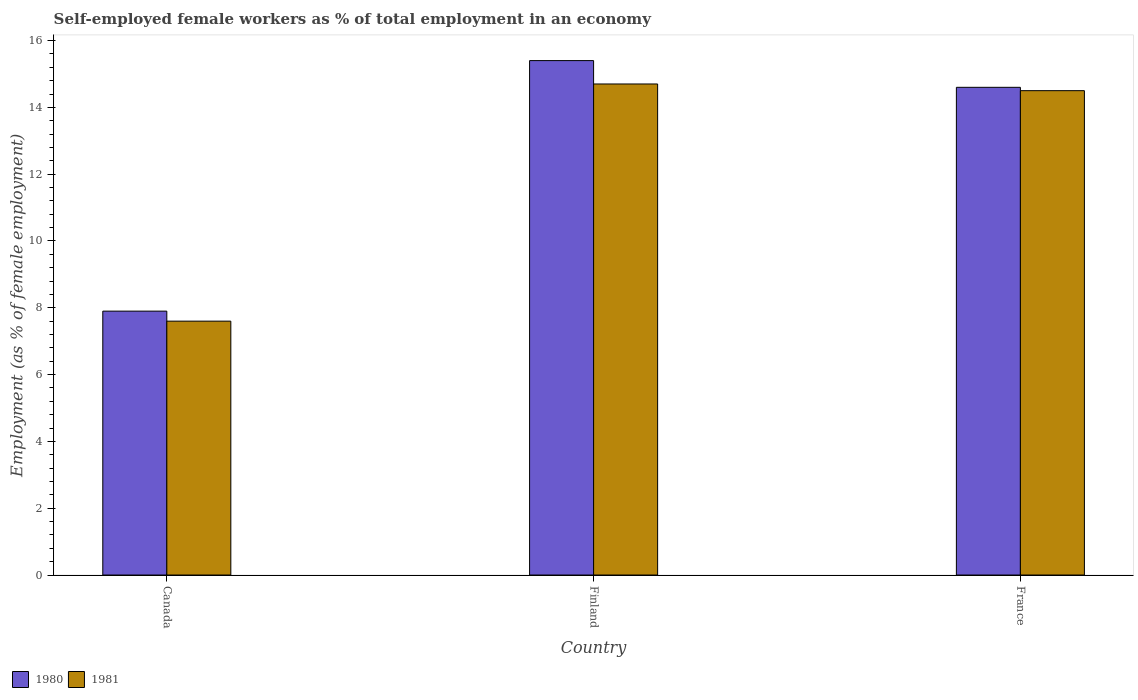How many different coloured bars are there?
Your response must be concise. 2. Are the number of bars per tick equal to the number of legend labels?
Provide a succinct answer. Yes. What is the percentage of self-employed female workers in 1981 in France?
Your answer should be compact. 14.5. Across all countries, what is the maximum percentage of self-employed female workers in 1981?
Offer a very short reply. 14.7. Across all countries, what is the minimum percentage of self-employed female workers in 1981?
Keep it short and to the point. 7.6. In which country was the percentage of self-employed female workers in 1981 maximum?
Your answer should be compact. Finland. What is the total percentage of self-employed female workers in 1980 in the graph?
Make the answer very short. 37.9. What is the difference between the percentage of self-employed female workers in 1980 in Canada and that in France?
Offer a terse response. -6.7. What is the difference between the percentage of self-employed female workers in 1981 in France and the percentage of self-employed female workers in 1980 in Finland?
Provide a succinct answer. -0.9. What is the average percentage of self-employed female workers in 1981 per country?
Ensure brevity in your answer.  12.27. What is the difference between the percentage of self-employed female workers of/in 1980 and percentage of self-employed female workers of/in 1981 in Canada?
Make the answer very short. 0.3. What is the ratio of the percentage of self-employed female workers in 1980 in Canada to that in Finland?
Your response must be concise. 0.51. Is the percentage of self-employed female workers in 1980 in Canada less than that in France?
Ensure brevity in your answer.  Yes. What is the difference between the highest and the second highest percentage of self-employed female workers in 1980?
Your answer should be compact. -6.7. What is the difference between the highest and the lowest percentage of self-employed female workers in 1980?
Provide a succinct answer. 7.5. In how many countries, is the percentage of self-employed female workers in 1980 greater than the average percentage of self-employed female workers in 1980 taken over all countries?
Your response must be concise. 2. Is the sum of the percentage of self-employed female workers in 1980 in Finland and France greater than the maximum percentage of self-employed female workers in 1981 across all countries?
Give a very brief answer. Yes. How many bars are there?
Make the answer very short. 6. Are all the bars in the graph horizontal?
Offer a very short reply. No. How many countries are there in the graph?
Ensure brevity in your answer.  3. What is the difference between two consecutive major ticks on the Y-axis?
Provide a short and direct response. 2. Are the values on the major ticks of Y-axis written in scientific E-notation?
Your answer should be very brief. No. Does the graph contain any zero values?
Ensure brevity in your answer.  No. Where does the legend appear in the graph?
Offer a terse response. Bottom left. How are the legend labels stacked?
Provide a succinct answer. Horizontal. What is the title of the graph?
Your response must be concise. Self-employed female workers as % of total employment in an economy. What is the label or title of the X-axis?
Make the answer very short. Country. What is the label or title of the Y-axis?
Your answer should be compact. Employment (as % of female employment). What is the Employment (as % of female employment) in 1980 in Canada?
Your answer should be compact. 7.9. What is the Employment (as % of female employment) in 1981 in Canada?
Provide a short and direct response. 7.6. What is the Employment (as % of female employment) in 1980 in Finland?
Make the answer very short. 15.4. What is the Employment (as % of female employment) of 1981 in Finland?
Ensure brevity in your answer.  14.7. What is the Employment (as % of female employment) of 1980 in France?
Your answer should be compact. 14.6. What is the Employment (as % of female employment) in 1981 in France?
Make the answer very short. 14.5. Across all countries, what is the maximum Employment (as % of female employment) of 1980?
Give a very brief answer. 15.4. Across all countries, what is the maximum Employment (as % of female employment) of 1981?
Offer a very short reply. 14.7. Across all countries, what is the minimum Employment (as % of female employment) in 1980?
Your response must be concise. 7.9. Across all countries, what is the minimum Employment (as % of female employment) of 1981?
Provide a succinct answer. 7.6. What is the total Employment (as % of female employment) in 1980 in the graph?
Provide a succinct answer. 37.9. What is the total Employment (as % of female employment) of 1981 in the graph?
Your response must be concise. 36.8. What is the difference between the Employment (as % of female employment) of 1980 in Canada and that in Finland?
Offer a very short reply. -7.5. What is the difference between the Employment (as % of female employment) of 1981 in Canada and that in Finland?
Your answer should be very brief. -7.1. What is the difference between the Employment (as % of female employment) of 1980 in Canada and that in France?
Offer a very short reply. -6.7. What is the difference between the Employment (as % of female employment) in 1981 in Canada and that in France?
Your answer should be compact. -6.9. What is the difference between the Employment (as % of female employment) of 1980 in Finland and that in France?
Provide a succinct answer. 0.8. What is the difference between the Employment (as % of female employment) in 1981 in Finland and that in France?
Give a very brief answer. 0.2. What is the average Employment (as % of female employment) in 1980 per country?
Your response must be concise. 12.63. What is the average Employment (as % of female employment) in 1981 per country?
Offer a terse response. 12.27. What is the difference between the Employment (as % of female employment) in 1980 and Employment (as % of female employment) in 1981 in Finland?
Give a very brief answer. 0.7. What is the difference between the Employment (as % of female employment) in 1980 and Employment (as % of female employment) in 1981 in France?
Make the answer very short. 0.1. What is the ratio of the Employment (as % of female employment) in 1980 in Canada to that in Finland?
Provide a short and direct response. 0.51. What is the ratio of the Employment (as % of female employment) in 1981 in Canada to that in Finland?
Your response must be concise. 0.52. What is the ratio of the Employment (as % of female employment) in 1980 in Canada to that in France?
Your answer should be very brief. 0.54. What is the ratio of the Employment (as % of female employment) of 1981 in Canada to that in France?
Offer a terse response. 0.52. What is the ratio of the Employment (as % of female employment) of 1980 in Finland to that in France?
Provide a succinct answer. 1.05. What is the ratio of the Employment (as % of female employment) of 1981 in Finland to that in France?
Your answer should be very brief. 1.01. What is the difference between the highest and the second highest Employment (as % of female employment) in 1981?
Give a very brief answer. 0.2. What is the difference between the highest and the lowest Employment (as % of female employment) in 1981?
Keep it short and to the point. 7.1. 